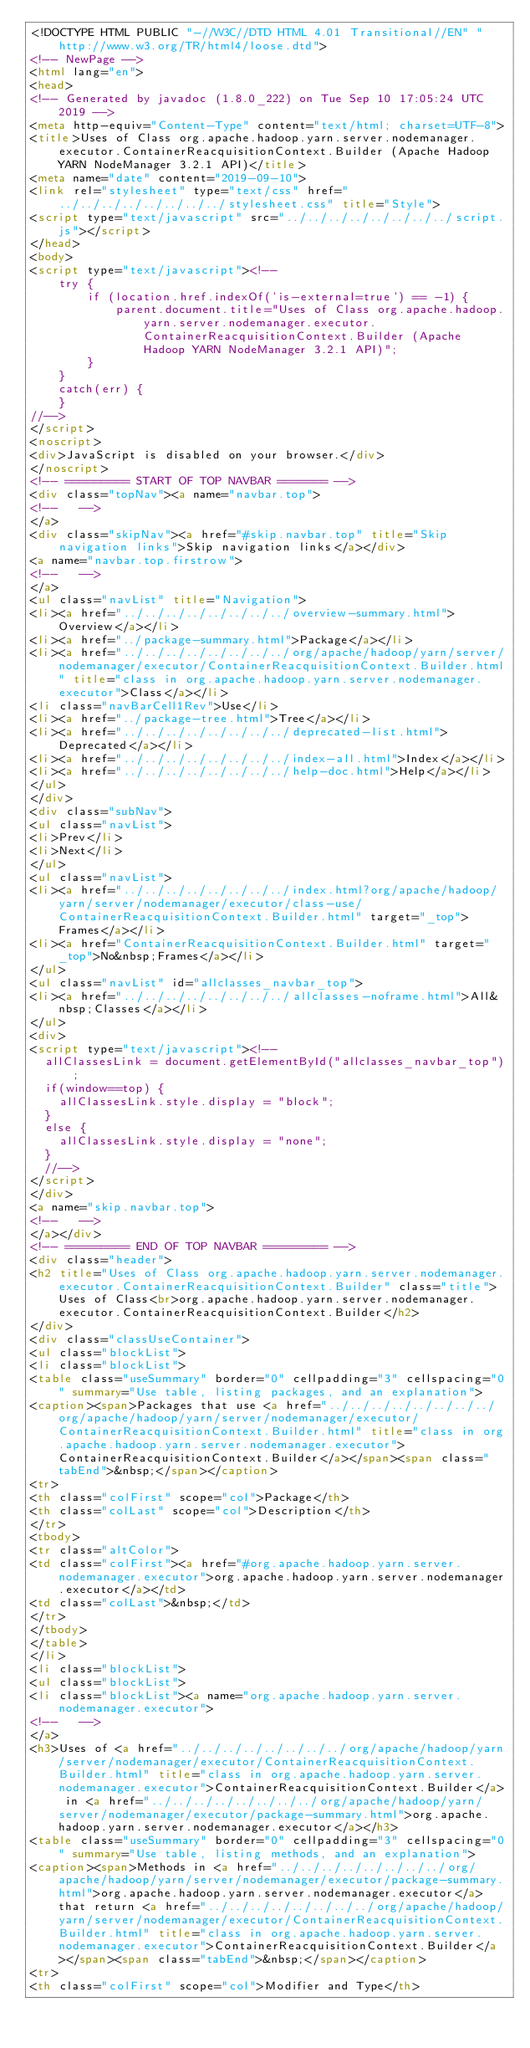<code> <loc_0><loc_0><loc_500><loc_500><_HTML_><!DOCTYPE HTML PUBLIC "-//W3C//DTD HTML 4.01 Transitional//EN" "http://www.w3.org/TR/html4/loose.dtd">
<!-- NewPage -->
<html lang="en">
<head>
<!-- Generated by javadoc (1.8.0_222) on Tue Sep 10 17:05:24 UTC 2019 -->
<meta http-equiv="Content-Type" content="text/html; charset=UTF-8">
<title>Uses of Class org.apache.hadoop.yarn.server.nodemanager.executor.ContainerReacquisitionContext.Builder (Apache Hadoop YARN NodeManager 3.2.1 API)</title>
<meta name="date" content="2019-09-10">
<link rel="stylesheet" type="text/css" href="../../../../../../../../stylesheet.css" title="Style">
<script type="text/javascript" src="../../../../../../../../script.js"></script>
</head>
<body>
<script type="text/javascript"><!--
    try {
        if (location.href.indexOf('is-external=true') == -1) {
            parent.document.title="Uses of Class org.apache.hadoop.yarn.server.nodemanager.executor.ContainerReacquisitionContext.Builder (Apache Hadoop YARN NodeManager 3.2.1 API)";
        }
    }
    catch(err) {
    }
//-->
</script>
<noscript>
<div>JavaScript is disabled on your browser.</div>
</noscript>
<!-- ========= START OF TOP NAVBAR ======= -->
<div class="topNav"><a name="navbar.top">
<!--   -->
</a>
<div class="skipNav"><a href="#skip.navbar.top" title="Skip navigation links">Skip navigation links</a></div>
<a name="navbar.top.firstrow">
<!--   -->
</a>
<ul class="navList" title="Navigation">
<li><a href="../../../../../../../../overview-summary.html">Overview</a></li>
<li><a href="../package-summary.html">Package</a></li>
<li><a href="../../../../../../../../org/apache/hadoop/yarn/server/nodemanager/executor/ContainerReacquisitionContext.Builder.html" title="class in org.apache.hadoop.yarn.server.nodemanager.executor">Class</a></li>
<li class="navBarCell1Rev">Use</li>
<li><a href="../package-tree.html">Tree</a></li>
<li><a href="../../../../../../../../deprecated-list.html">Deprecated</a></li>
<li><a href="../../../../../../../../index-all.html">Index</a></li>
<li><a href="../../../../../../../../help-doc.html">Help</a></li>
</ul>
</div>
<div class="subNav">
<ul class="navList">
<li>Prev</li>
<li>Next</li>
</ul>
<ul class="navList">
<li><a href="../../../../../../../../index.html?org/apache/hadoop/yarn/server/nodemanager/executor/class-use/ContainerReacquisitionContext.Builder.html" target="_top">Frames</a></li>
<li><a href="ContainerReacquisitionContext.Builder.html" target="_top">No&nbsp;Frames</a></li>
</ul>
<ul class="navList" id="allclasses_navbar_top">
<li><a href="../../../../../../../../allclasses-noframe.html">All&nbsp;Classes</a></li>
</ul>
<div>
<script type="text/javascript"><!--
  allClassesLink = document.getElementById("allclasses_navbar_top");
  if(window==top) {
    allClassesLink.style.display = "block";
  }
  else {
    allClassesLink.style.display = "none";
  }
  //-->
</script>
</div>
<a name="skip.navbar.top">
<!--   -->
</a></div>
<!-- ========= END OF TOP NAVBAR ========= -->
<div class="header">
<h2 title="Uses of Class org.apache.hadoop.yarn.server.nodemanager.executor.ContainerReacquisitionContext.Builder" class="title">Uses of Class<br>org.apache.hadoop.yarn.server.nodemanager.executor.ContainerReacquisitionContext.Builder</h2>
</div>
<div class="classUseContainer">
<ul class="blockList">
<li class="blockList">
<table class="useSummary" border="0" cellpadding="3" cellspacing="0" summary="Use table, listing packages, and an explanation">
<caption><span>Packages that use <a href="../../../../../../../../org/apache/hadoop/yarn/server/nodemanager/executor/ContainerReacquisitionContext.Builder.html" title="class in org.apache.hadoop.yarn.server.nodemanager.executor">ContainerReacquisitionContext.Builder</a></span><span class="tabEnd">&nbsp;</span></caption>
<tr>
<th class="colFirst" scope="col">Package</th>
<th class="colLast" scope="col">Description</th>
</tr>
<tbody>
<tr class="altColor">
<td class="colFirst"><a href="#org.apache.hadoop.yarn.server.nodemanager.executor">org.apache.hadoop.yarn.server.nodemanager.executor</a></td>
<td class="colLast">&nbsp;</td>
</tr>
</tbody>
</table>
</li>
<li class="blockList">
<ul class="blockList">
<li class="blockList"><a name="org.apache.hadoop.yarn.server.nodemanager.executor">
<!--   -->
</a>
<h3>Uses of <a href="../../../../../../../../org/apache/hadoop/yarn/server/nodemanager/executor/ContainerReacquisitionContext.Builder.html" title="class in org.apache.hadoop.yarn.server.nodemanager.executor">ContainerReacquisitionContext.Builder</a> in <a href="../../../../../../../../org/apache/hadoop/yarn/server/nodemanager/executor/package-summary.html">org.apache.hadoop.yarn.server.nodemanager.executor</a></h3>
<table class="useSummary" border="0" cellpadding="3" cellspacing="0" summary="Use table, listing methods, and an explanation">
<caption><span>Methods in <a href="../../../../../../../../org/apache/hadoop/yarn/server/nodemanager/executor/package-summary.html">org.apache.hadoop.yarn.server.nodemanager.executor</a> that return <a href="../../../../../../../../org/apache/hadoop/yarn/server/nodemanager/executor/ContainerReacquisitionContext.Builder.html" title="class in org.apache.hadoop.yarn.server.nodemanager.executor">ContainerReacquisitionContext.Builder</a></span><span class="tabEnd">&nbsp;</span></caption>
<tr>
<th class="colFirst" scope="col">Modifier and Type</th></code> 